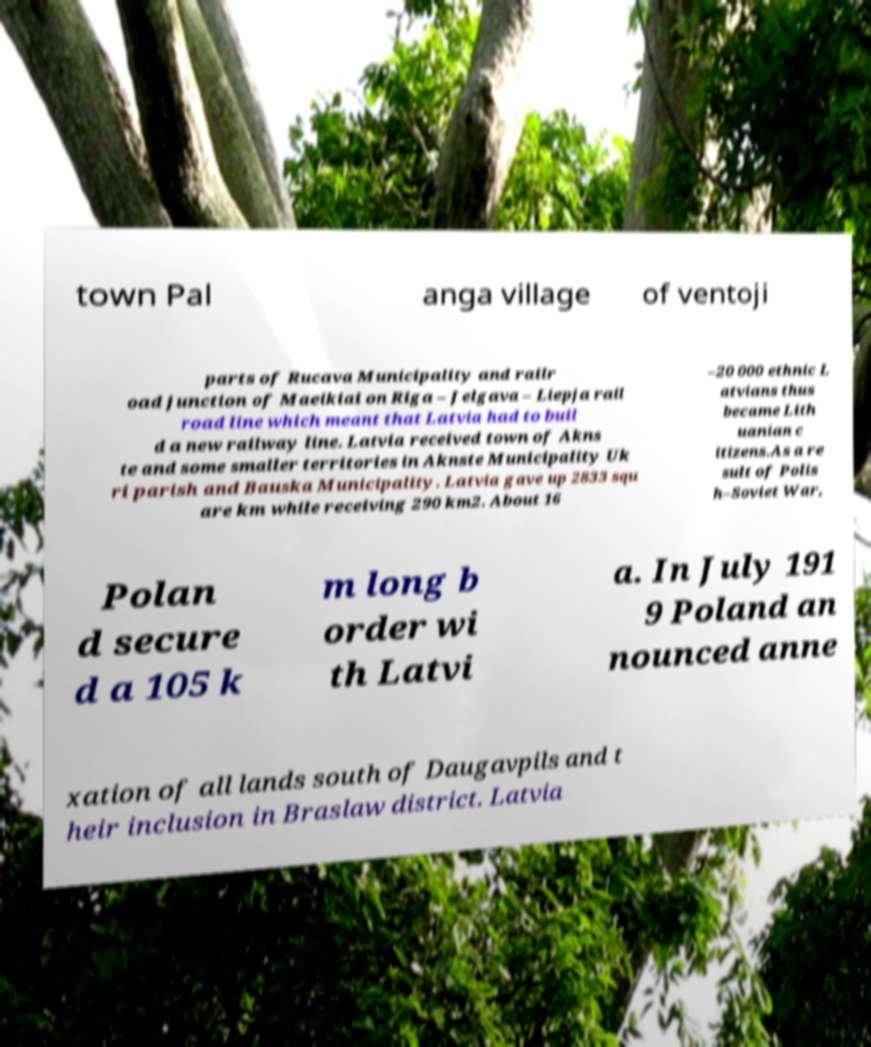What messages or text are displayed in this image? I need them in a readable, typed format. town Pal anga village of ventoji parts of Rucava Municipality and railr oad junction of Maeikiai on Riga – Jelgava – Liepja rail road line which meant that Latvia had to buil d a new railway line. Latvia received town of Akns te and some smaller territories in Aknste Municipality Uk ri parish and Bauska Municipality. Latvia gave up 2833 squ are km while receiving 290 km2. About 16 –20 000 ethnic L atvians thus became Lith uanian c itizens.As a re sult of Polis h–Soviet War, Polan d secure d a 105 k m long b order wi th Latvi a. In July 191 9 Poland an nounced anne xation of all lands south of Daugavpils and t heir inclusion in Braslaw district. Latvia 